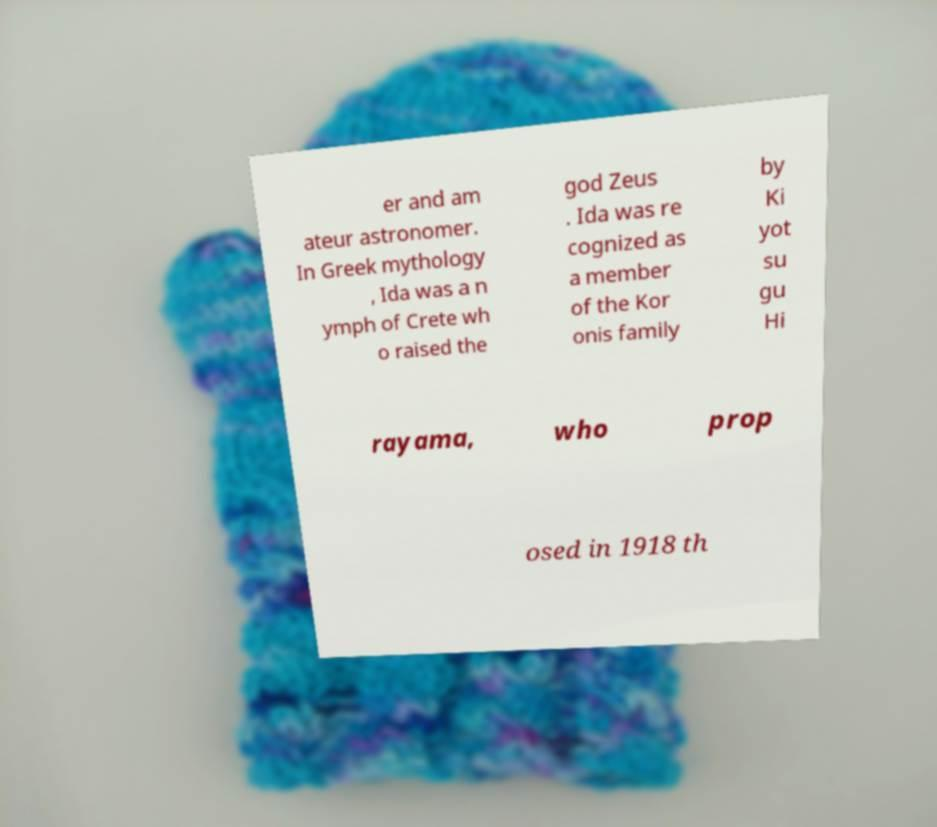Can you read and provide the text displayed in the image?This photo seems to have some interesting text. Can you extract and type it out for me? er and am ateur astronomer. In Greek mythology , Ida was a n ymph of Crete wh o raised the god Zeus . Ida was re cognized as a member of the Kor onis family by Ki yot su gu Hi rayama, who prop osed in 1918 th 